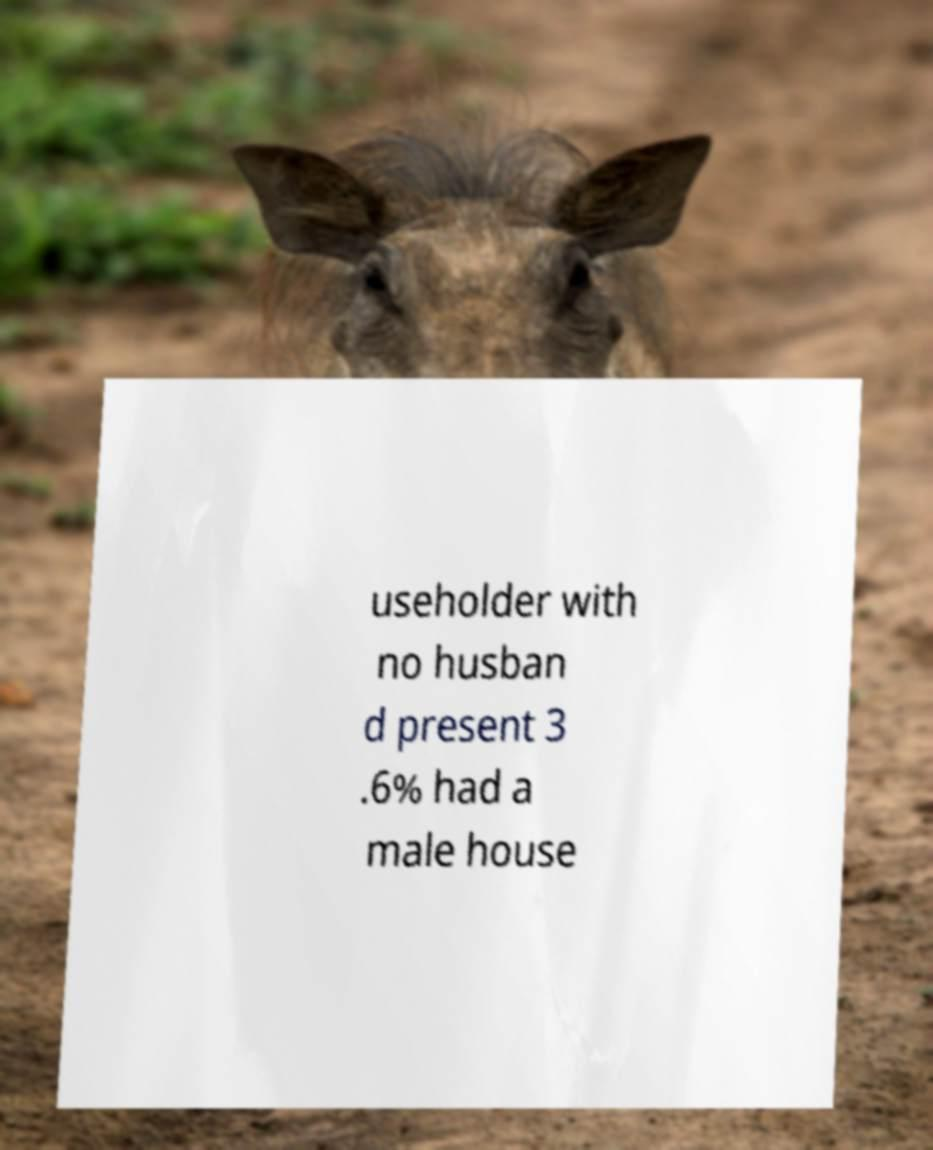There's text embedded in this image that I need extracted. Can you transcribe it verbatim? useholder with no husban d present 3 .6% had a male house 